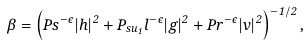Convert formula to latex. <formula><loc_0><loc_0><loc_500><loc_500>\beta = \left ( P s ^ { - \epsilon } | h | ^ { 2 } + P _ { s u _ { 1 } } l ^ { - \epsilon } | g | ^ { 2 } + P r ^ { - \epsilon } | v | ^ { 2 } \right ) ^ { - 1 / 2 } ,</formula> 